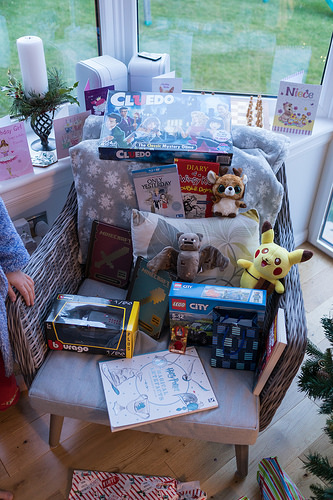<image>
Can you confirm if the book is on the chair? Yes. Looking at the image, I can see the book is positioned on top of the chair, with the chair providing support. 